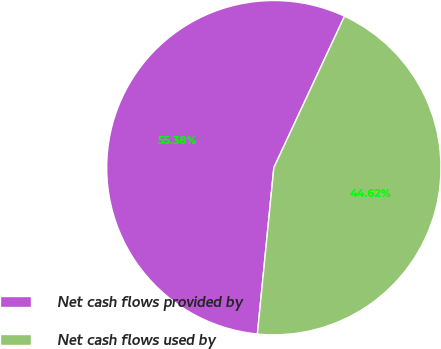Convert chart to OTSL. <chart><loc_0><loc_0><loc_500><loc_500><pie_chart><fcel>Net cash flows provided by<fcel>Net cash flows used by<nl><fcel>55.38%<fcel>44.62%<nl></chart> 